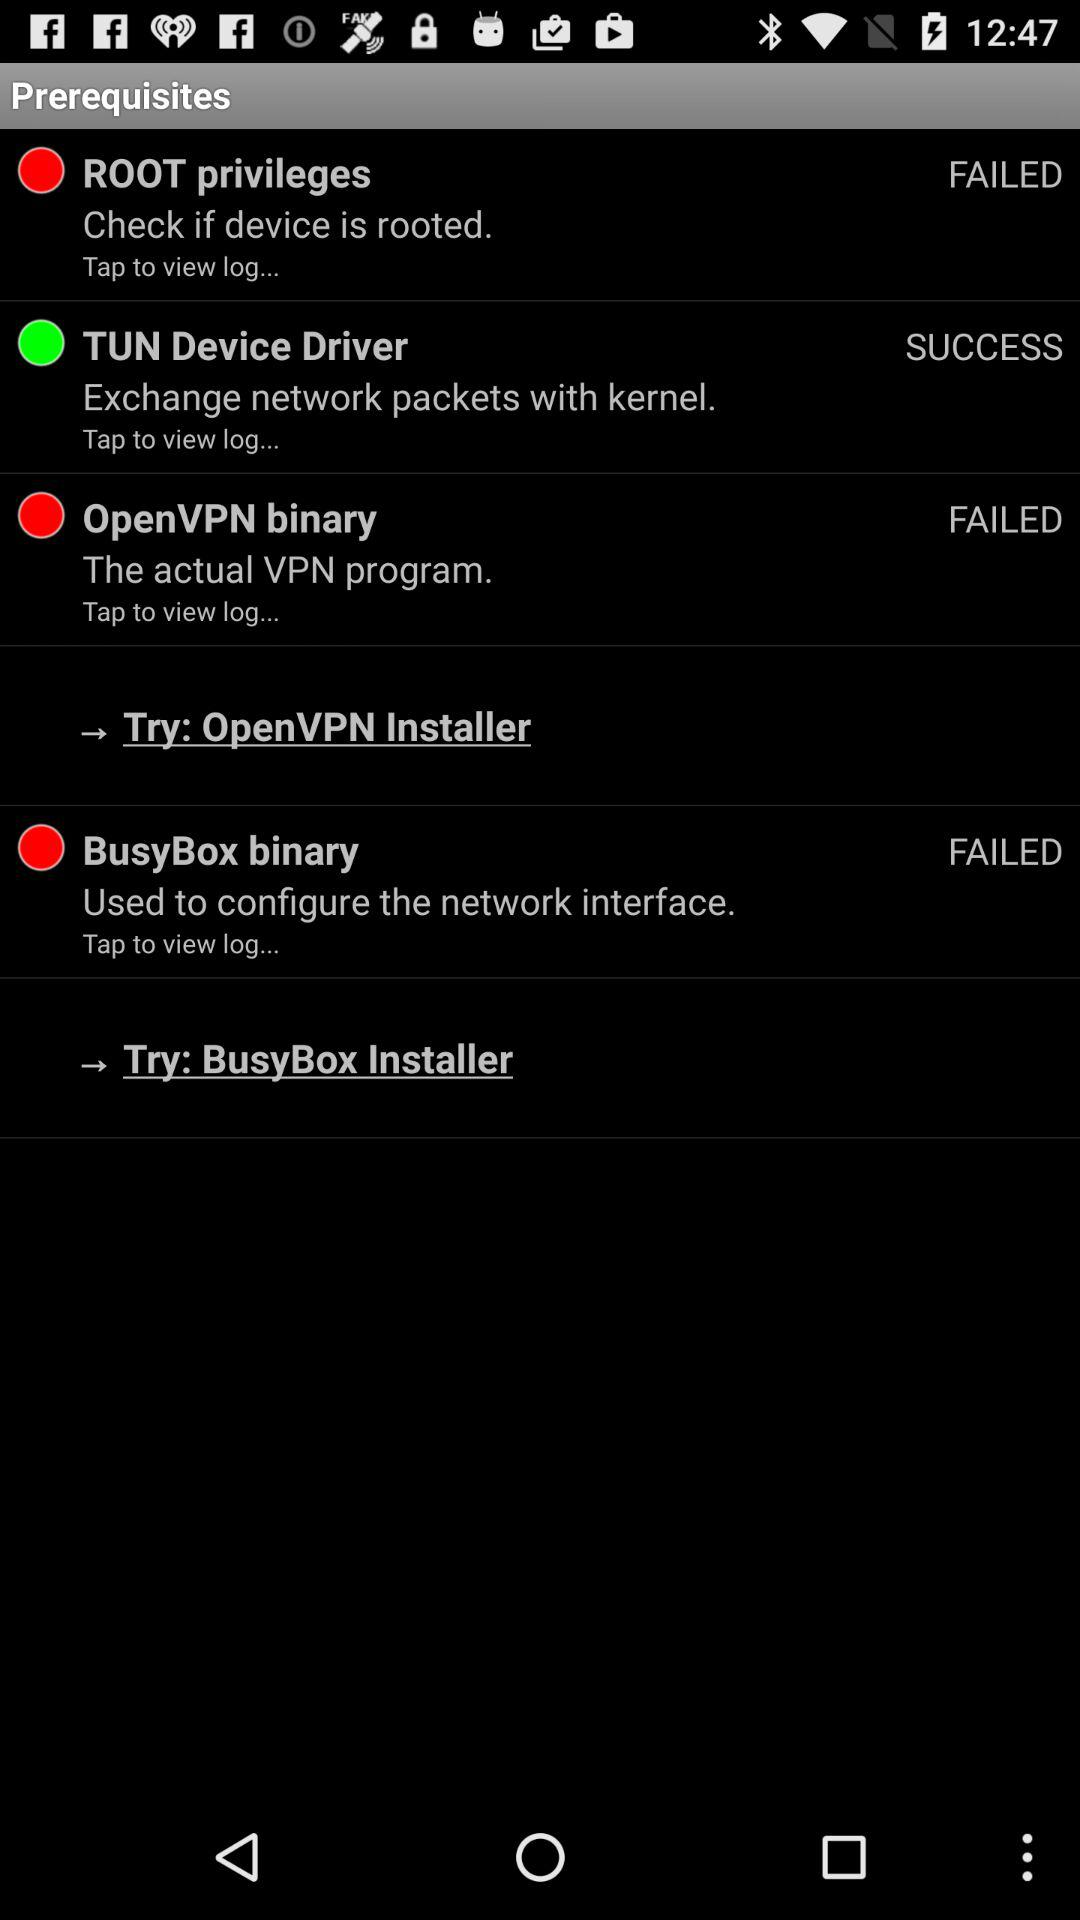Is the "BusyBox binary network interface" failed or successful?
Answer the question using a single word or phrase. It is "FAILED". 